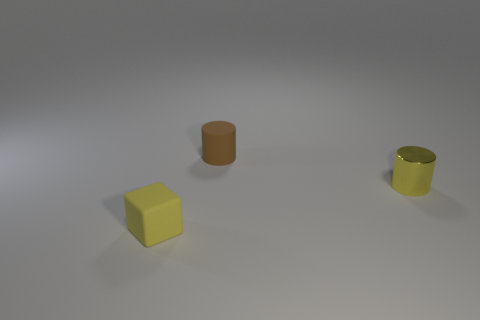What might be the purpose behind arranging these objects in this way? The arrangement of these objects might serve a few purposes. It could be a simple display of geometric shapes and colors for educational or illustrative purposes, demonstrating how similar objects of different colors look next to each other. Alternatively, it could be an artistic composition playing with the concepts of symmetry and asymmetry, or an arrangement for a visual perception study focusing on the spatial relationship between objects of different shapes and colors. 